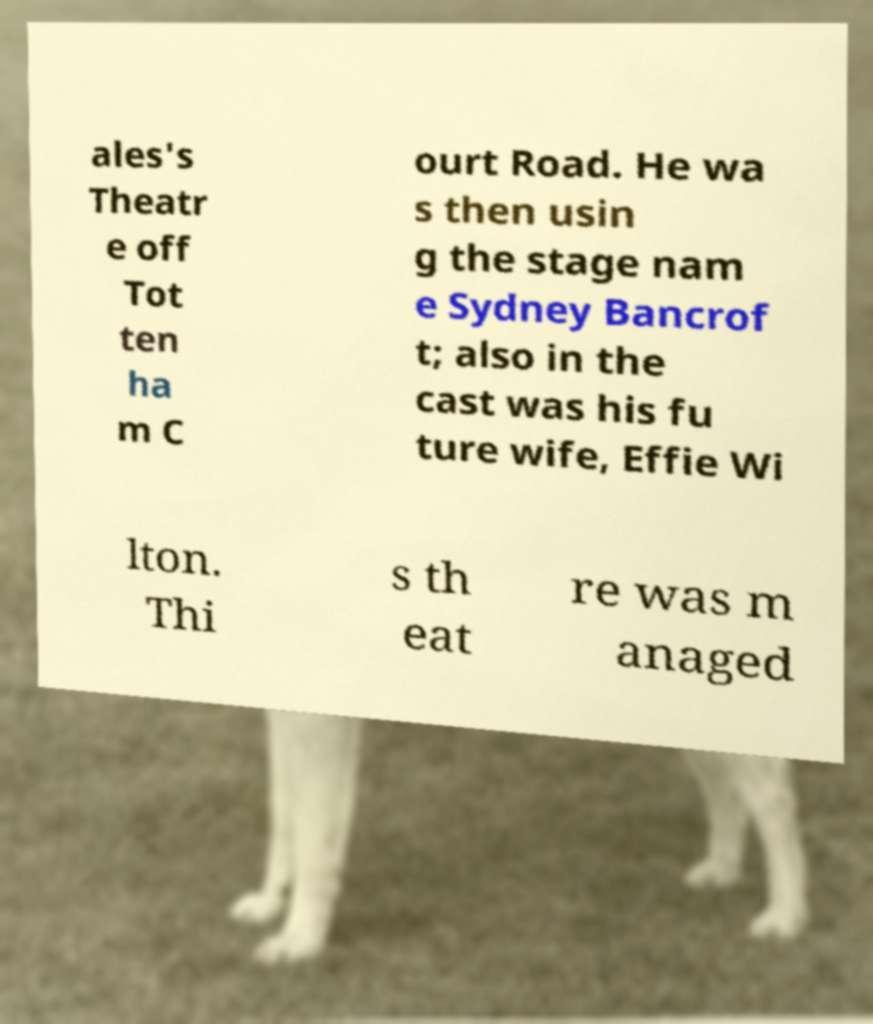For documentation purposes, I need the text within this image transcribed. Could you provide that? ales's Theatr e off Tot ten ha m C ourt Road. He wa s then usin g the stage nam e Sydney Bancrof t; also in the cast was his fu ture wife, Effie Wi lton. Thi s th eat re was m anaged 